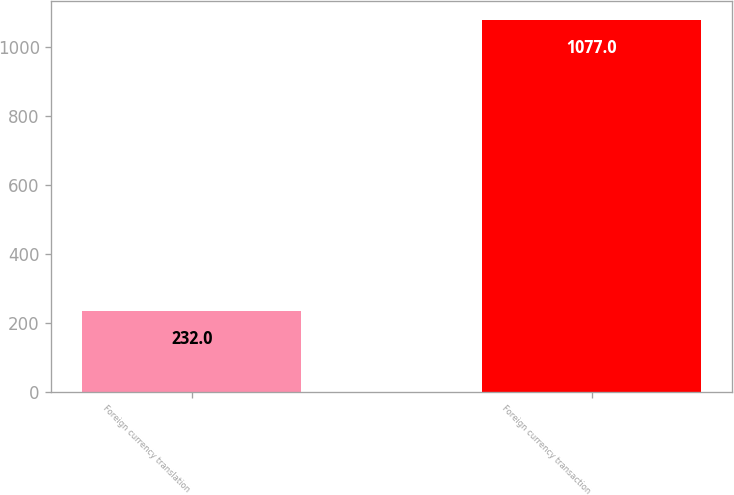Convert chart to OTSL. <chart><loc_0><loc_0><loc_500><loc_500><bar_chart><fcel>Foreign currency translation<fcel>Foreign currency transaction<nl><fcel>232<fcel>1077<nl></chart> 